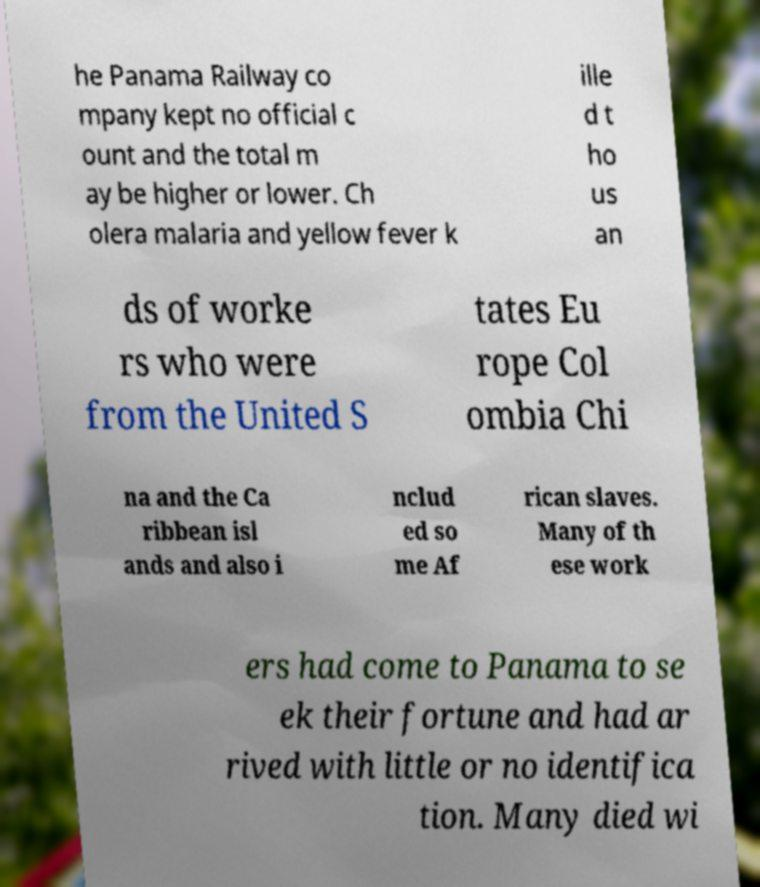Please identify and transcribe the text found in this image. he Panama Railway co mpany kept no official c ount and the total m ay be higher or lower. Ch olera malaria and yellow fever k ille d t ho us an ds of worke rs who were from the United S tates Eu rope Col ombia Chi na and the Ca ribbean isl ands and also i nclud ed so me Af rican slaves. Many of th ese work ers had come to Panama to se ek their fortune and had ar rived with little or no identifica tion. Many died wi 